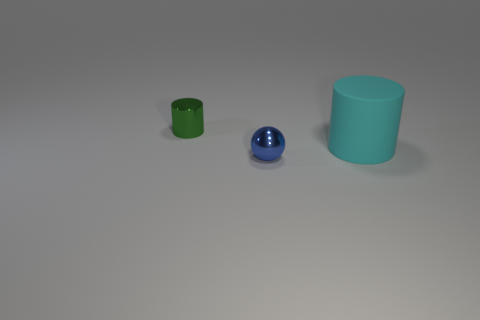What is the tiny blue thing made of?
Provide a short and direct response. Metal. There is a tiny object that is to the left of the small object that is on the right side of the metal thing behind the big cyan cylinder; what color is it?
Give a very brief answer. Green. What is the material of the green object that is the same shape as the big cyan thing?
Provide a succinct answer. Metal. How many green shiny objects have the same size as the blue thing?
Offer a terse response. 1. How many small blue matte objects are there?
Your answer should be compact. 0. Are the small blue object and the cylinder that is on the right side of the tiny green cylinder made of the same material?
Provide a short and direct response. No. What number of yellow things are either large rubber things or blocks?
Offer a terse response. 0. What is the size of the blue sphere that is the same material as the green cylinder?
Make the answer very short. Small. How many other green objects are the same shape as the tiny green metallic thing?
Offer a terse response. 0. Are there more tiny blue metal things on the right side of the small green metal cylinder than tiny spheres to the right of the tiny sphere?
Your response must be concise. Yes. 